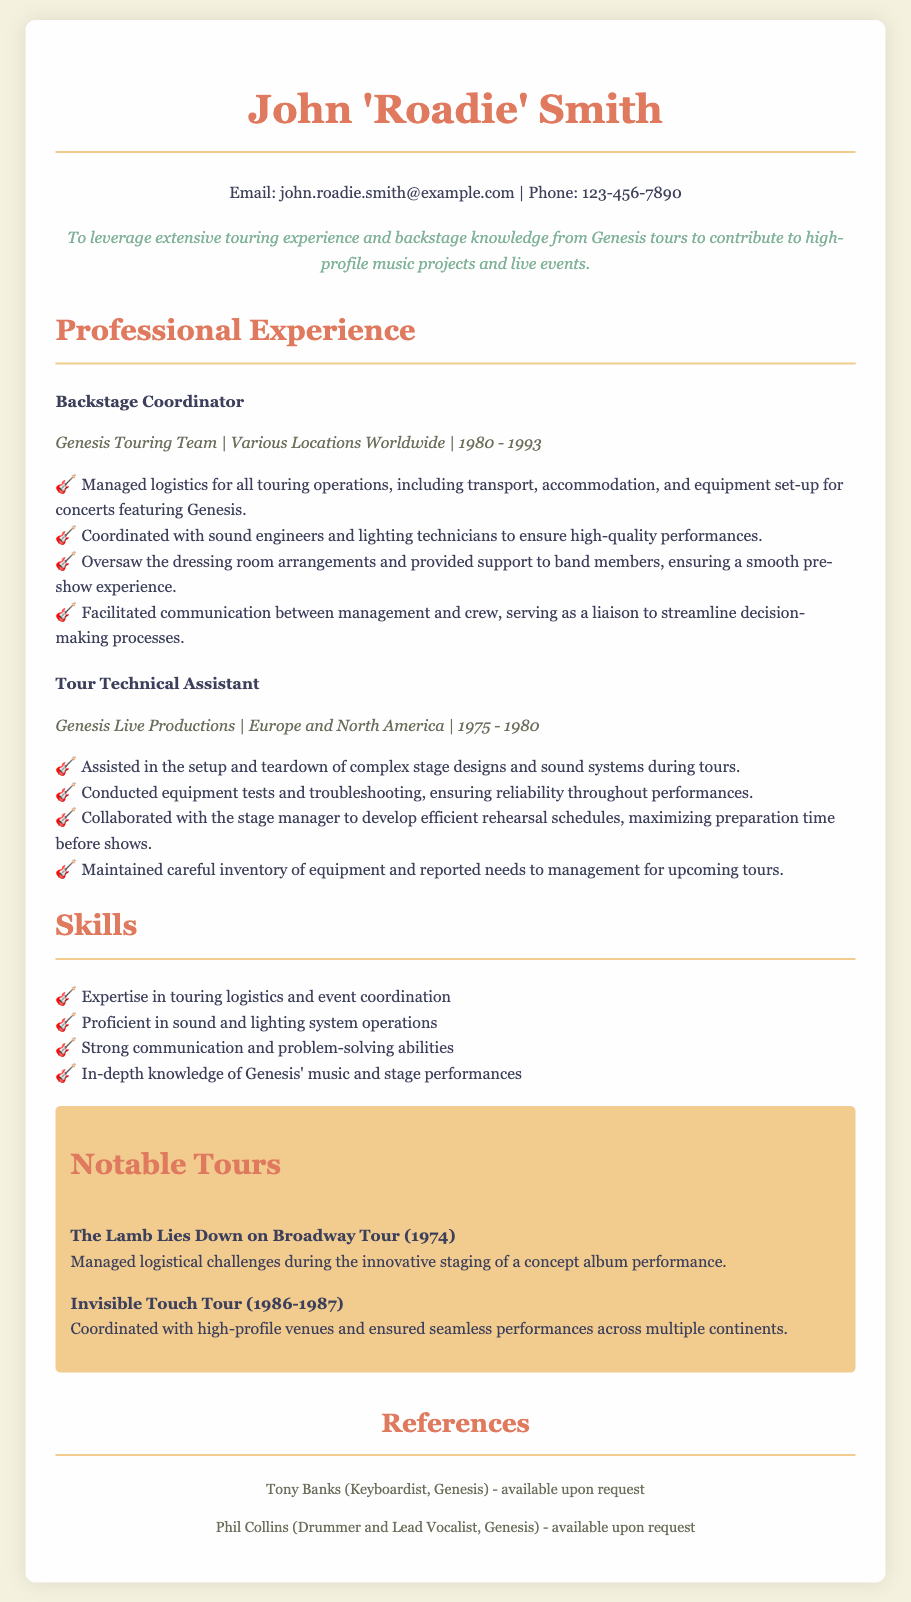what was John 'Roadie' Smith's role in Genesis? John 'Roadie' Smith served as a Backstage Coordinator, managing logistics for all touring operations.
Answer: Backstage Coordinator what years did John 'Roadie' Smith work with Genesis? He worked with Genesis from 1980 to 1993.
Answer: 1980 - 1993 which tour involved managing logistical challenges during a concept album performance? The Lamb Lies Down on Broadway Tour involved managing logistical challenges during an innovative staging.
Answer: The Lamb Lies Down on Broadway Tour how long did John 'Roadie' Smith work as a Tour Technical Assistant? He worked as a Tour Technical Assistant from 1975 to 1980, which is 5 years.
Answer: 5 years what skill indicates expertise in sound and lighting system operations? One of the mentioned skills is proficiency in sound and lighting system operations.
Answer: proficiency in sound and lighting system operations which notable tour occurred in 1986-1987? The notable tour that occurred during those years was the Invisible Touch Tour.
Answer: Invisible Touch Tour who can provide references upon request? Tony Banks and Phil Collins can both provide references upon request.
Answer: Tony Banks, Phil Collins what was the primary objective of John 'Roadie' Smith's CV? The objective was to leverage extensive touring experience and backstage knowledge from Genesis tours.
Answer: leverage extensive touring experience how many notable tours are mentioned in the document? There are two notable tours mentioned in the document.
Answer: two who was the keyboardist of Genesis mentioned in the references? The keyboardist of Genesis mentioned is Tony Banks.
Answer: Tony Banks 